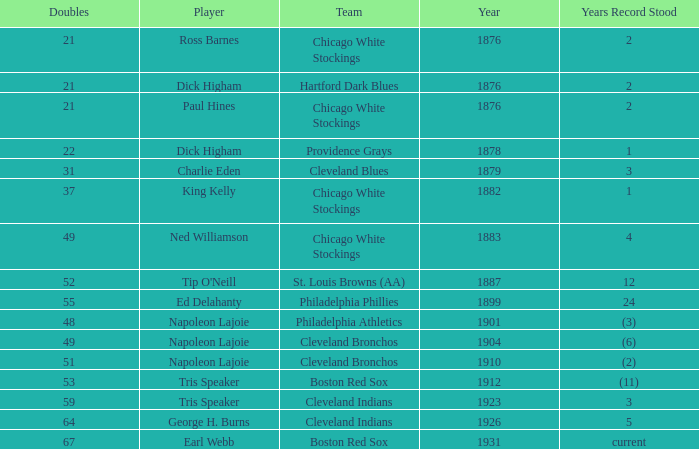During which year did napoleon lajoie's record of 49 doubles while playing for the cleveland bronchos stand? (6). 